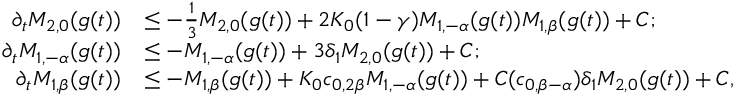<formula> <loc_0><loc_0><loc_500><loc_500>\begin{array} { r l } { \partial _ { t } M _ { 2 , 0 } ( g ( t ) ) } & { \leq - \frac { 1 } { 3 } M _ { 2 , 0 } ( g ( t ) ) + 2 K _ { 0 } ( 1 - \gamma ) M _ { 1 , - \alpha } ( g ( t ) ) M _ { 1 , \beta } ( g ( t ) ) + C ; } \\ { \partial _ { t } M _ { 1 , - \alpha } ( g ( t ) ) } & { \leq - M _ { 1 , - \alpha } ( g ( t ) ) + 3 \delta _ { 1 } M _ { 2 , 0 } ( g ( t ) ) + C ; } \\ { \partial _ { t } M _ { 1 , \beta } ( g ( t ) ) } & { \leq - M _ { 1 , \beta } ( g ( t ) ) + K _ { 0 } c _ { 0 , 2 \beta } M _ { 1 , - \alpha } ( g ( t ) ) + C ( c _ { 0 , \beta - \alpha } ) \delta _ { 1 } M _ { 2 , 0 } ( g ( t ) ) + C , } \end{array}</formula> 